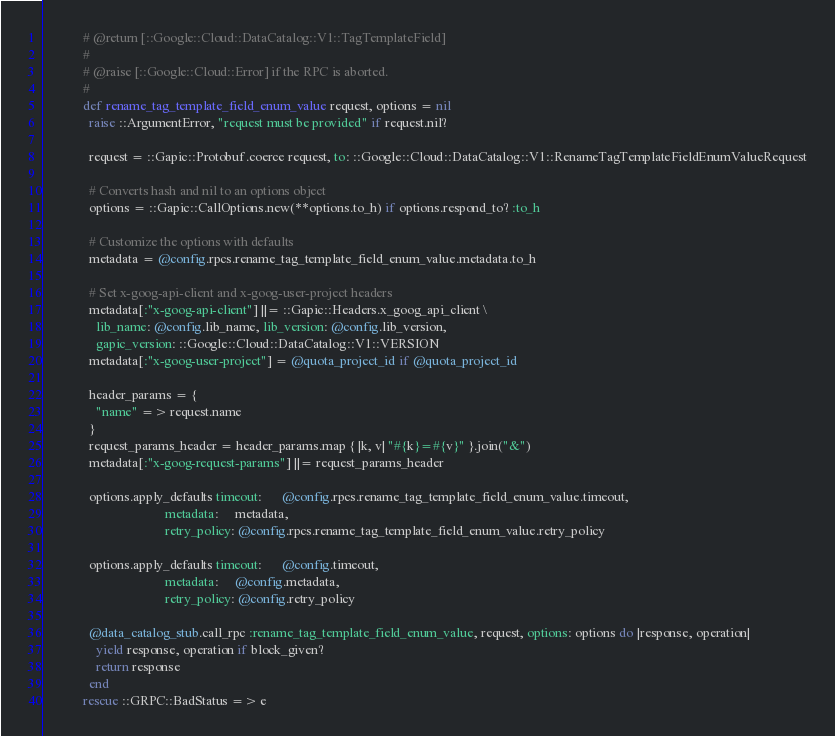<code> <loc_0><loc_0><loc_500><loc_500><_Ruby_>            # @return [::Google::Cloud::DataCatalog::V1::TagTemplateField]
            #
            # @raise [::Google::Cloud::Error] if the RPC is aborted.
            #
            def rename_tag_template_field_enum_value request, options = nil
              raise ::ArgumentError, "request must be provided" if request.nil?

              request = ::Gapic::Protobuf.coerce request, to: ::Google::Cloud::DataCatalog::V1::RenameTagTemplateFieldEnumValueRequest

              # Converts hash and nil to an options object
              options = ::Gapic::CallOptions.new(**options.to_h) if options.respond_to? :to_h

              # Customize the options with defaults
              metadata = @config.rpcs.rename_tag_template_field_enum_value.metadata.to_h

              # Set x-goog-api-client and x-goog-user-project headers
              metadata[:"x-goog-api-client"] ||= ::Gapic::Headers.x_goog_api_client \
                lib_name: @config.lib_name, lib_version: @config.lib_version,
                gapic_version: ::Google::Cloud::DataCatalog::V1::VERSION
              metadata[:"x-goog-user-project"] = @quota_project_id if @quota_project_id

              header_params = {
                "name" => request.name
              }
              request_params_header = header_params.map { |k, v| "#{k}=#{v}" }.join("&")
              metadata[:"x-goog-request-params"] ||= request_params_header

              options.apply_defaults timeout:      @config.rpcs.rename_tag_template_field_enum_value.timeout,
                                     metadata:     metadata,
                                     retry_policy: @config.rpcs.rename_tag_template_field_enum_value.retry_policy

              options.apply_defaults timeout:      @config.timeout,
                                     metadata:     @config.metadata,
                                     retry_policy: @config.retry_policy

              @data_catalog_stub.call_rpc :rename_tag_template_field_enum_value, request, options: options do |response, operation|
                yield response, operation if block_given?
                return response
              end
            rescue ::GRPC::BadStatus => e</code> 